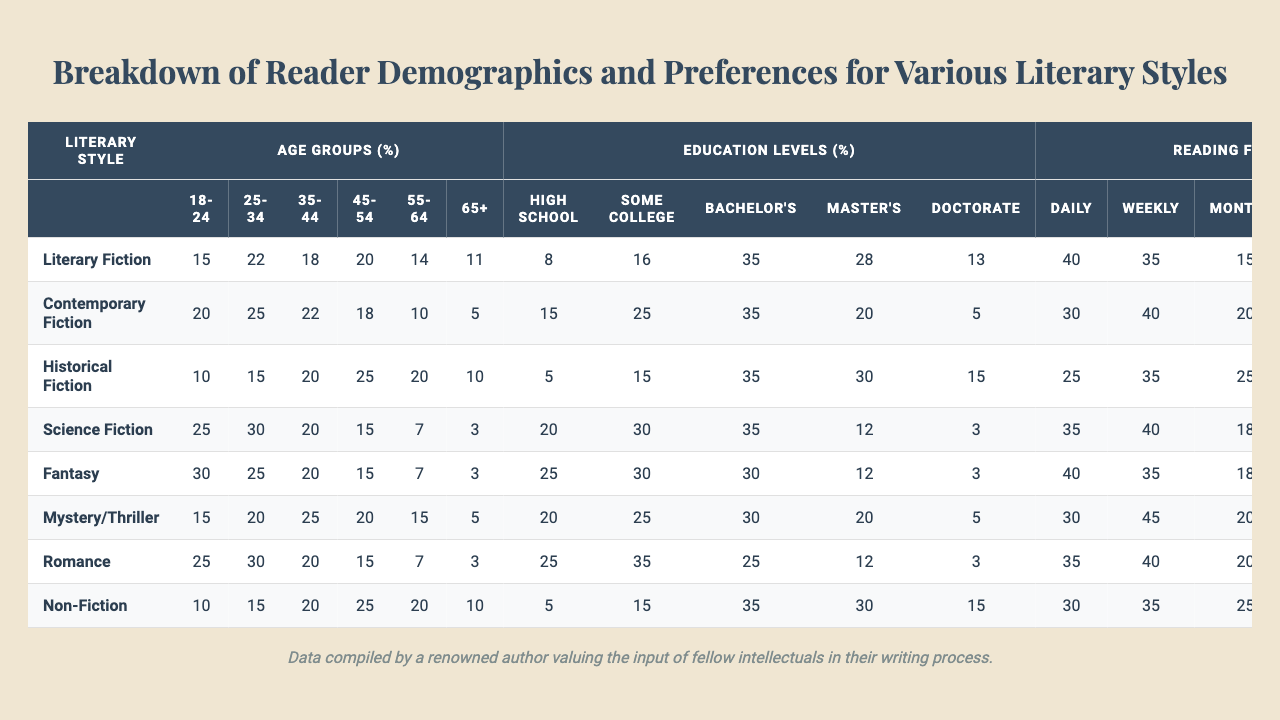What is the percentage of readers aged 18-24 who prefer Science Fiction? In the table under the "Science Fiction" literary style, the percentage for the age group "18-24" is listed as 25%
Answer: 25% How many more people aged 45-54 prefer Mystery/Thriller compared to those aged 65+? The percentage of readers aged 45-54 who prefer Mystery/Thriller is 20%, while those aged 65+ is 5%. The difference is 20% - 5% = 15%
Answer: 15% Which literary style has the highest percentage of readers with a Master's Degree? By examining the Education Levels for each literary style, "Historical Fiction" has 30%, which is the highest among all styles for readers with a Master's Degree
Answer: Historical Fiction Are the preferences for E-books higher in Romance than in Mystery/Thriller? For Romance, the percentage of E-book preference is 35%, while for Mystery/Thriller, it is 30%. Thus, the preference is higher in Romance
Answer: Yes What is the total percentage of readers who read Literary Fiction daily and weekly? Daily readers for Literary Fiction is 40% and Weekly readers is 35%. The total is 40% + 35% = 75%
Answer: 75% Which age group has the highest participation in reading Fantasy? Looking at the percentages for the Fantasy literary style, the age group "18-24" has the highest percentage at 30%
Answer: 18-24 Identify the educational qualification that has the lowest engagement in Historical Fiction. The lowest percentage for Historical Fiction under Education Levels is for "High School", which is 5%
Answer: High School How do the preferences for the Paperback format compare between Non-Fiction and Historical Fiction? For Non-Fiction, the preference for Paperback is 25%, whereas for Historical Fiction, it is 30%. Historical Fiction has higher preference
Answer: Historical Fiction What is the average reading frequency for readers of Contemporary Fiction? Adding the percentages for each reading frequency: 30% (Daily) + 40% (Weekly) + 20% (Monthly) + 8% (Quarterly) + 2% (Yearly) = 100%, and then finding the average: (30 + 40 + 20 + 8 + 2) / 5 = 20
Answer: 20 Is there a greater preference for Hardcover or Audiobook among readers of Literary Fiction? The percentages show that for Literary Fiction, 30% prefer Hardcover and 10% prefer Audiobook. Hardcover preference is greater
Answer: Hardcover 